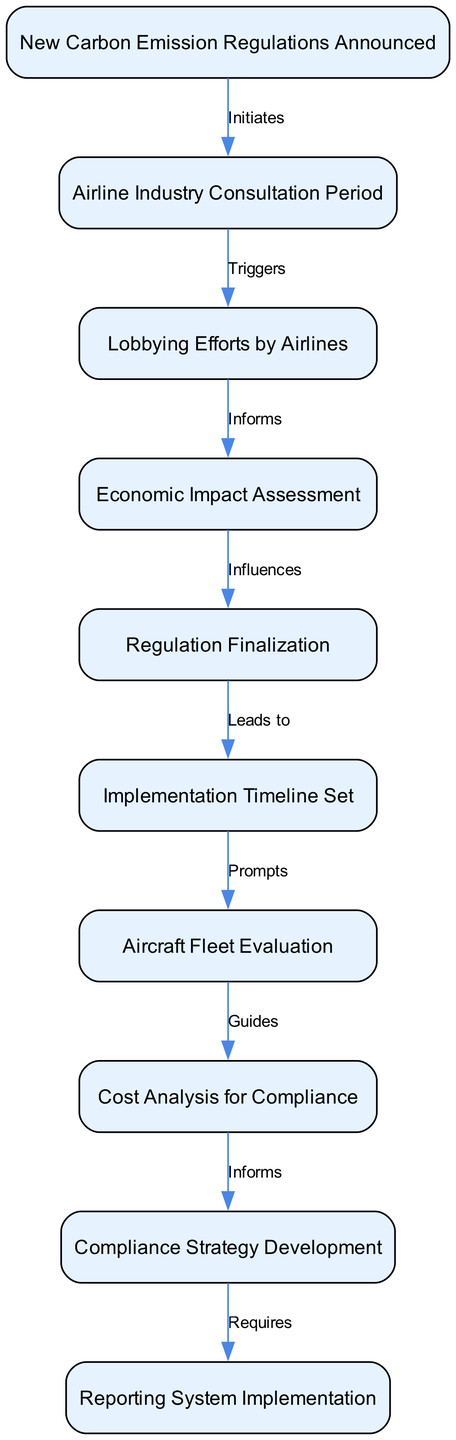What is the first step in the process? The first step is represented by the node labeled "New Carbon Emission Regulations Announced," indicating that the announcement of these regulations initiates the process.
Answer: New Carbon Emission Regulations Announced How many nodes are in the diagram? By counting each unique step or action in the process represented by the nodes, we find that there are a total of 10 nodes in the diagram.
Answer: 10 What node follows the "Economic Impact Assessment"? The node that follows "Economic Impact Assessment" is labeled "Regulation Finalization," which indicates the direct flow from assessing the economic impact to finalizing the regulations.
Answer: Regulation Finalization What action does the "Airline Industry Consultation Period" trigger? The "Airline Industry Consultation Period" triggers "Lobbying Efforts by Airlines," indicating that after the consultation period, airlines engage in lobbying.
Answer: Lobbying Efforts by Airlines What prompts the "Aircraft Fleet Evaluation"? The action labeled "Implementation Timeline Set" prompts the "Aircraft Fleet Evaluation," meaning that once the timeline for implementation is established, airlines need to evaluate their aircraft fleet.
Answer: Aircraft Fleet Evaluation How many relationships are illustrated in the diagram? To find the number of relationships, we can count the edges connecting the nodes, which total 9 edges in this diagram.
Answer: 9 What does the "Cost Analysis for Compliance" inform? The "Cost Analysis for Compliance" informs the "Compliance Strategy Development," indicating that the cost analysis is crucial for shaping how the airlines will comply with the regulations.
Answer: Compliance Strategy Development What is required after developing the compliance strategy? The node "Reporting System Implementation" is required after developing the compliance strategy, indicating that a system for reporting compliance is essential.
Answer: Reporting System Implementation Which node influences the "Regulation Finalization"? The node "Economic Impact Assessment" influences the "Regulation Finalization," showing that the assessment of economic impacts plays a key role in how regulations are finalized.
Answer: Economic Impact Assessment 